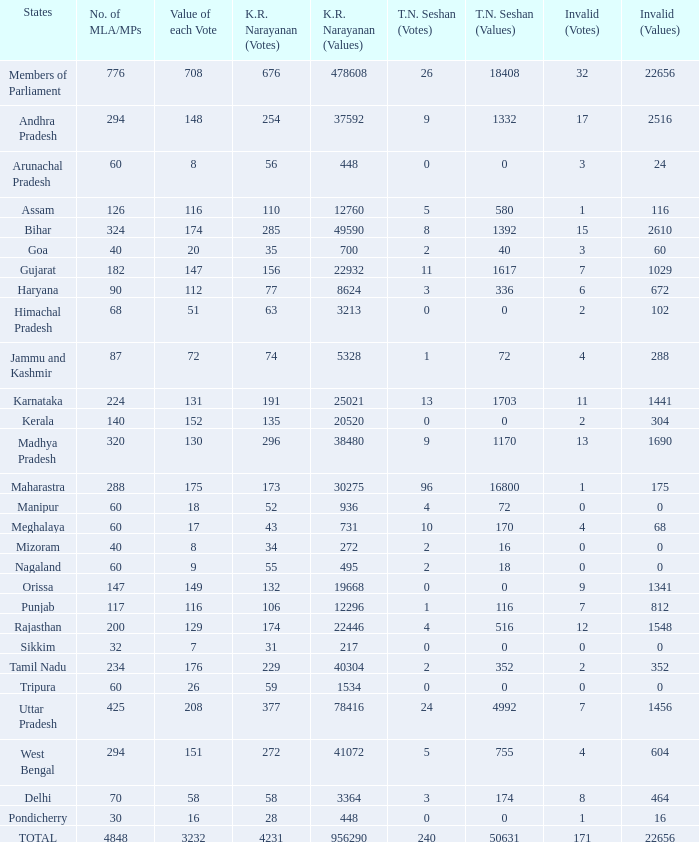Name the number of tn seshan values for kr values is 478608 1.0. 